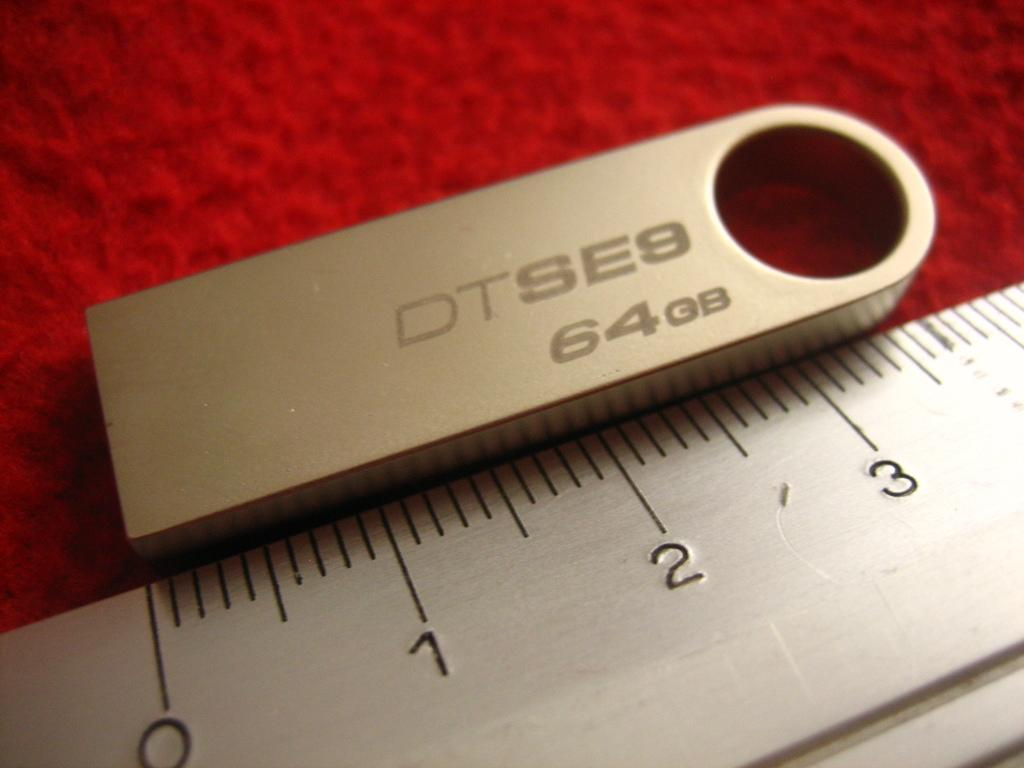<image>
Describe the image concisely. A 64 GB golden thumb drive is being measured with a metal ruler. 